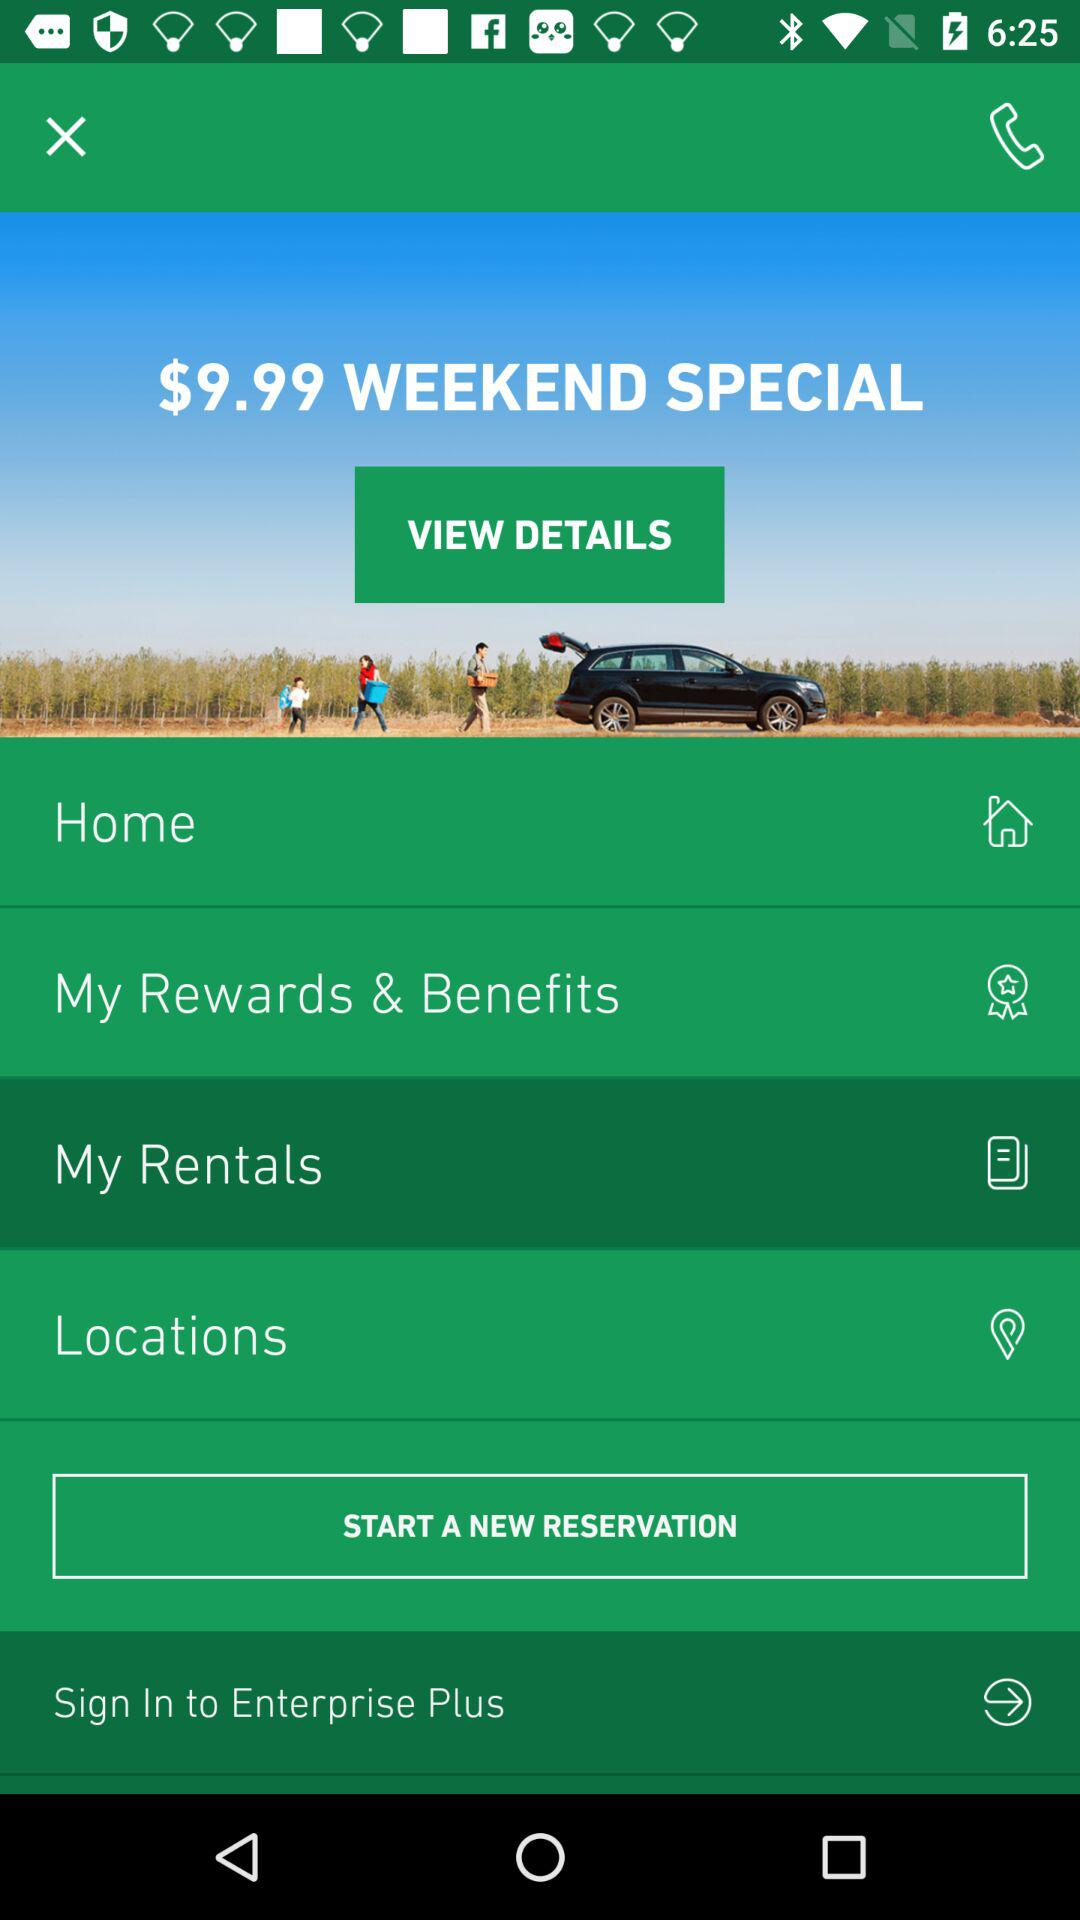What is the application name? The application name is "Enterprise Plus". 